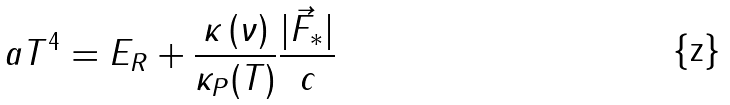<formula> <loc_0><loc_0><loc_500><loc_500>a T ^ { 4 } = E _ { R } + \frac { \kappa \left ( \nu \right ) } { \kappa _ { P } ( T ) } \frac { | \vec { F } _ { * } | } { c }</formula> 